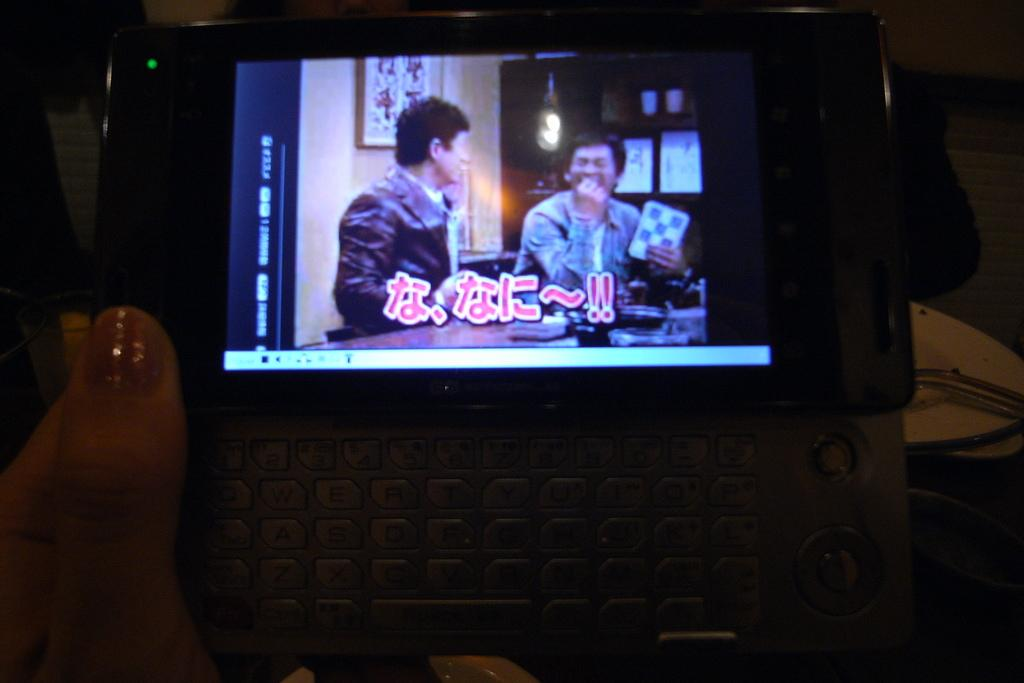What is the person in the image holding? The person is holding a device in the image. What feature does the device have? The device has a screen. Can you describe the background of the image? There are objects visible in the background of the image. Reasoning: Let' Let's think step by step in order to produce the conversation. We start by identifying the main subject in the image, which is the person holding a device. Then, we describe the device's specific feature, which is its screen. Finally, we acknowledge the presence of objects in the background, providing a sense of the image's setting. Absurd Question/Answer: What type of humor can be seen in the beggar's performance in the image? There is no beggar present in the image, and therefore no performance or humor can be observed. 